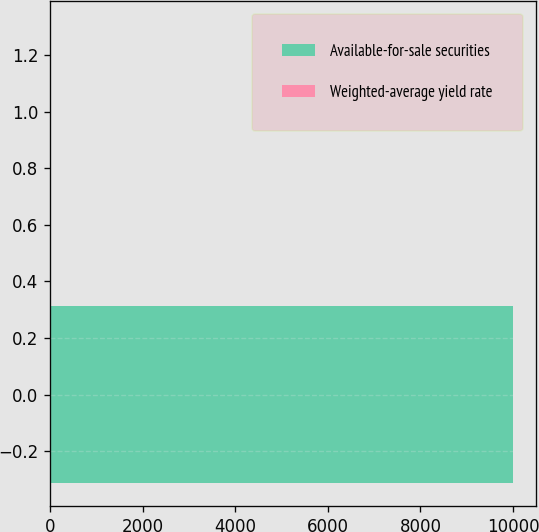Convert chart to OTSL. <chart><loc_0><loc_0><loc_500><loc_500><bar_chart><fcel>Available-for-sale securities<fcel>Weighted-average yield rate<nl><fcel>9995<fcel>1<nl></chart> 